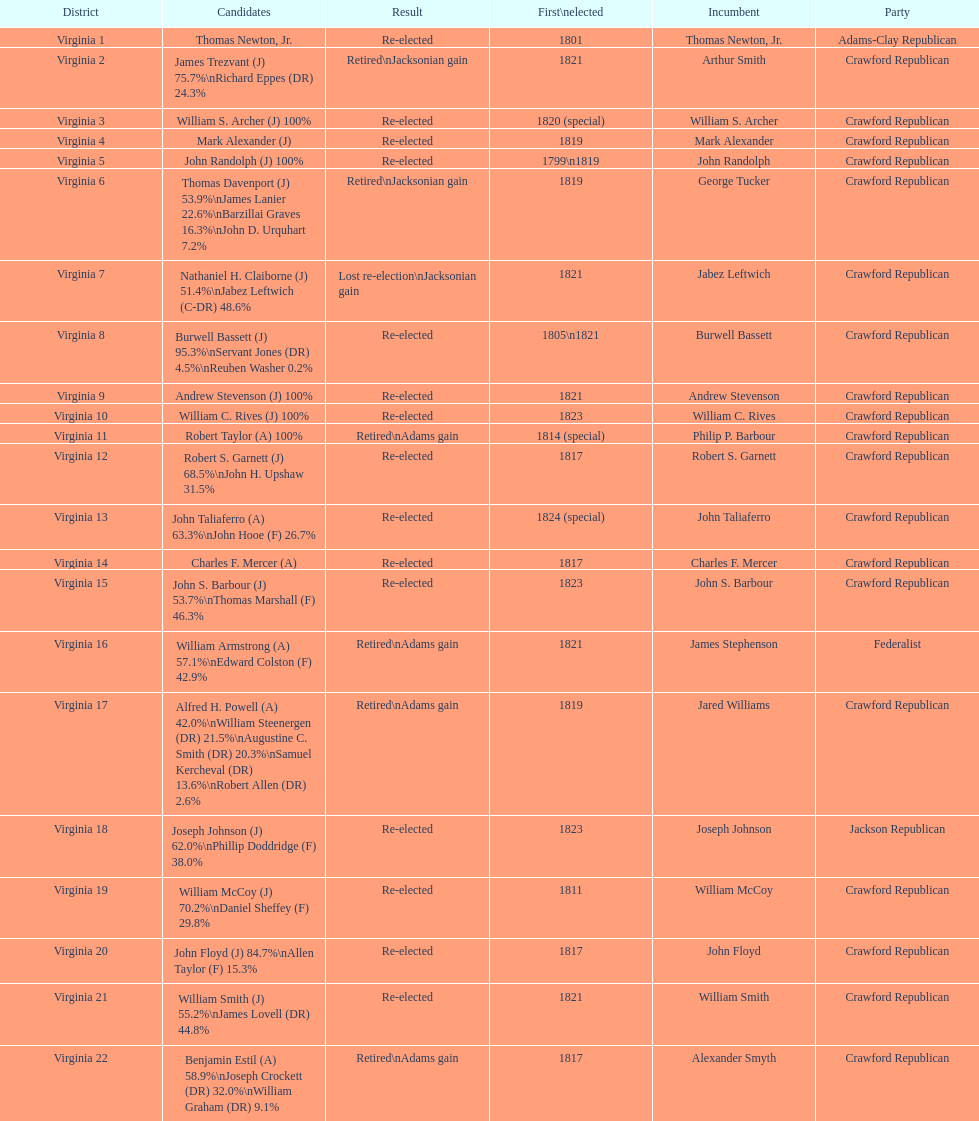Number of incumbents who retired or lost re-election 7. 